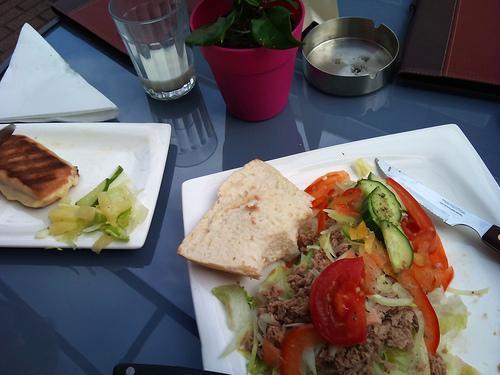How many plates are pictured?
Give a very brief answer. 2. 